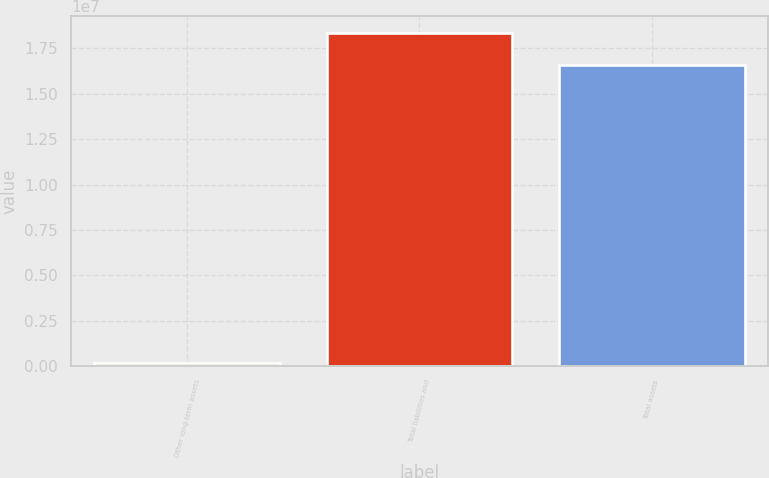Convert chart. <chart><loc_0><loc_0><loc_500><loc_500><bar_chart><fcel>Other long-term assets<fcel>Total liabilities and<fcel>Total assets<nl><fcel>163128<fcel>1.83419e+07<fcel>1.66113e+07<nl></chart> 